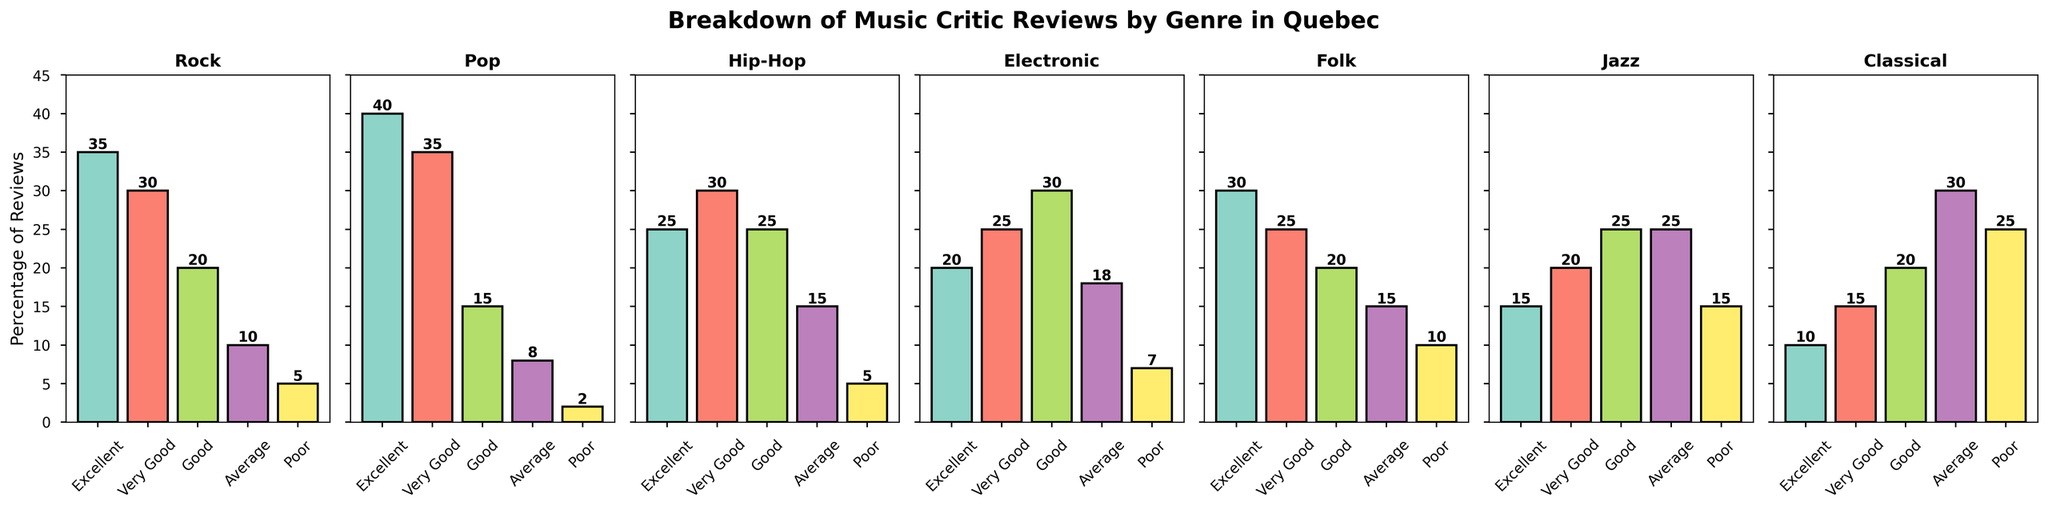Which genre received the highest number of 'Excellent' reviews? Visually comparing the bar heights for the 'Excellent' category across all genres, the highest bar corresponds to the Pop genre, which has 40 reviews.
Answer: Pop Which genre has the least 'Poor' reviews? By looking at the heights of the 'Poor' category bars, the genre with the shortest bar is Pop with only 2 reviews marked as 'Poor'.
Answer: Pop What is the total percentage of 'Very Good' reviews for Rock and Pop combined? Adding the 'Very Good' reviews for Rock (30) and Pop (35), we get a total of 65%.
Answer: 65% Compare the 'Good' reviews between Electronic and Jazz. Which one is higher and by how much? Electronic has 30 'Good' reviews, while Jazz has 25. The difference is 30 - 25 = 5 reviews.
Answer: Electronic by 5 reviews Among Jazz, which category has the second highest number of reviews? For Jazz, the highest number of reviews is in the 'Average' category with 25, followed closely by the 'Very Good' category with 20 reviews.
Answer: Very Good How many 'Average' reviews are there for Classical and Folk combined? Adding the 'Average' reviews for Classical (30) and Folk (15), we get a total of 30 + 15 = 45.
Answer: 45 In which genre do 'Good' reviews make up exactly 25% of total reviews? Checking the 'Good' reviews across genres, we find that Hip-Hop has 25 reviews under 'Good', equating to 25%.
Answer: Hip-Hop What is the total percentage of non-'Excellent' reviews for the Electronic genre? Summing up the non-'Excellent' reviews in Electronic (25+30+18+7), the total is 80%.
Answer: 80% Which genre has the highest variation in review categories based on bar heights? Visually assessing the variation in bar heights across review categories, the Rock genre shows significant differences with values ranging from 35 (Excellent) to 5 (Poor).
Answer: Rock Which two genres have equal numbers of 'Average' reviews? Both Jazz and Classical have 25 'Average' reviews each.
Answer: Jazz and Classical 